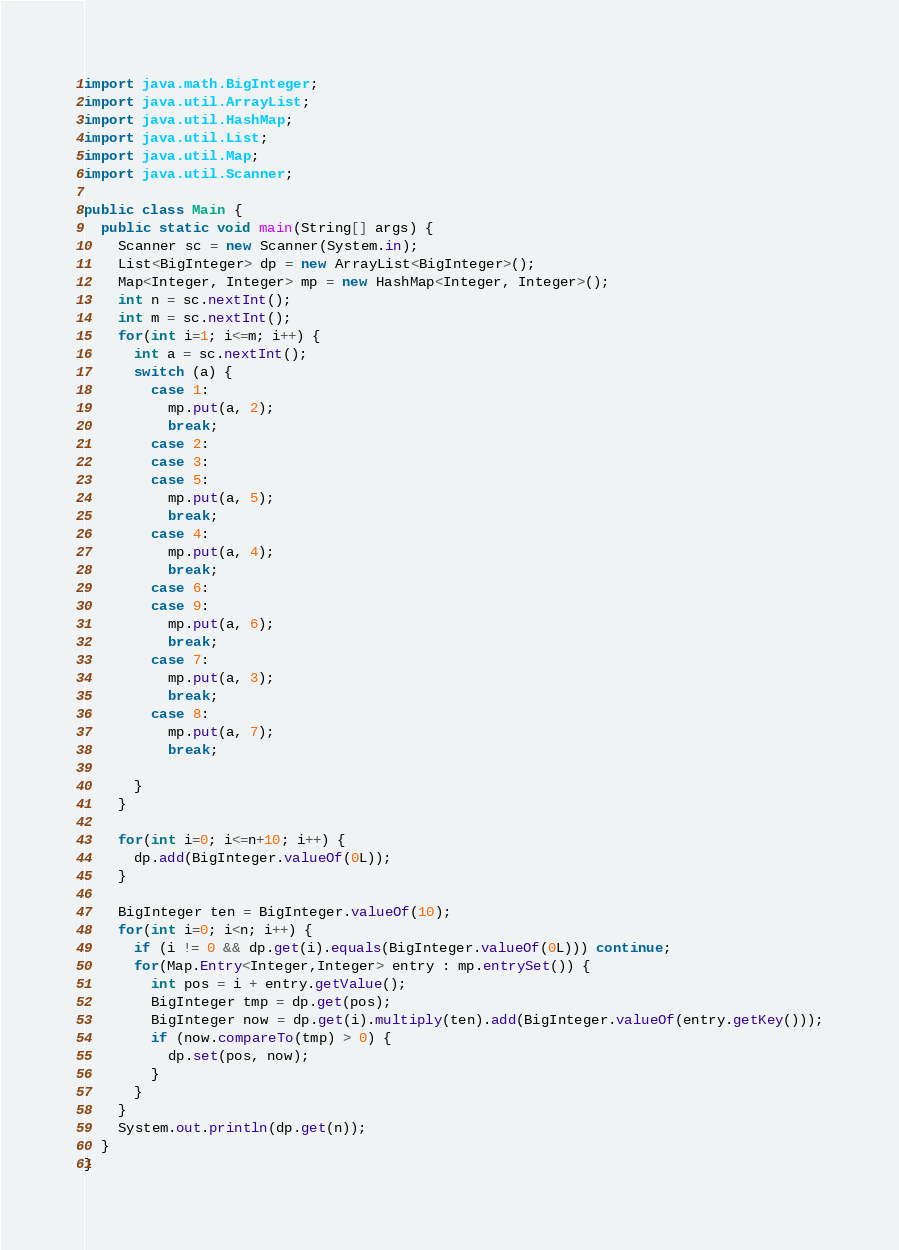Convert code to text. <code><loc_0><loc_0><loc_500><loc_500><_Java_>import java.math.BigInteger;
import java.util.ArrayList;
import java.util.HashMap;
import java.util.List;
import java.util.Map;
import java.util.Scanner;
    
public class Main {
  public static void main(String[] args) {
    Scanner sc = new Scanner(System.in);
    List<BigInteger> dp = new ArrayList<BigInteger>();
    Map<Integer, Integer> mp = new HashMap<Integer, Integer>();
    int n = sc.nextInt();
    int m = sc.nextInt();
    for(int i=1; i<=m; i++) {
      int a = sc.nextInt();
      switch (a) {
        case 1:
          mp.put(a, 2);
          break;
        case 2:
        case 3:
        case 5:
          mp.put(a, 5);
          break;
        case 4:
          mp.put(a, 4);
          break;
        case 6:
        case 9:
          mp.put(a, 6);
          break;
        case 7:
          mp.put(a, 3);
          break;
        case 8:
          mp.put(a, 7);
          break;

      }
    }
    
    for(int i=0; i<=n+10; i++) {
      dp.add(BigInteger.valueOf(0L));
    }
    
    BigInteger ten = BigInteger.valueOf(10);
    for(int i=0; i<n; i++) {
      if (i != 0 && dp.get(i).equals(BigInteger.valueOf(0L))) continue;
      for(Map.Entry<Integer,Integer> entry : mp.entrySet()) {
        int pos = i + entry.getValue();
        BigInteger tmp = dp.get(pos);
        BigInteger now = dp.get(i).multiply(ten).add(BigInteger.valueOf(entry.getKey()));
        if (now.compareTo(tmp) > 0) {
          dp.set(pos, now);
        }
      }
    }
    System.out.println(dp.get(n));
  }
}
</code> 